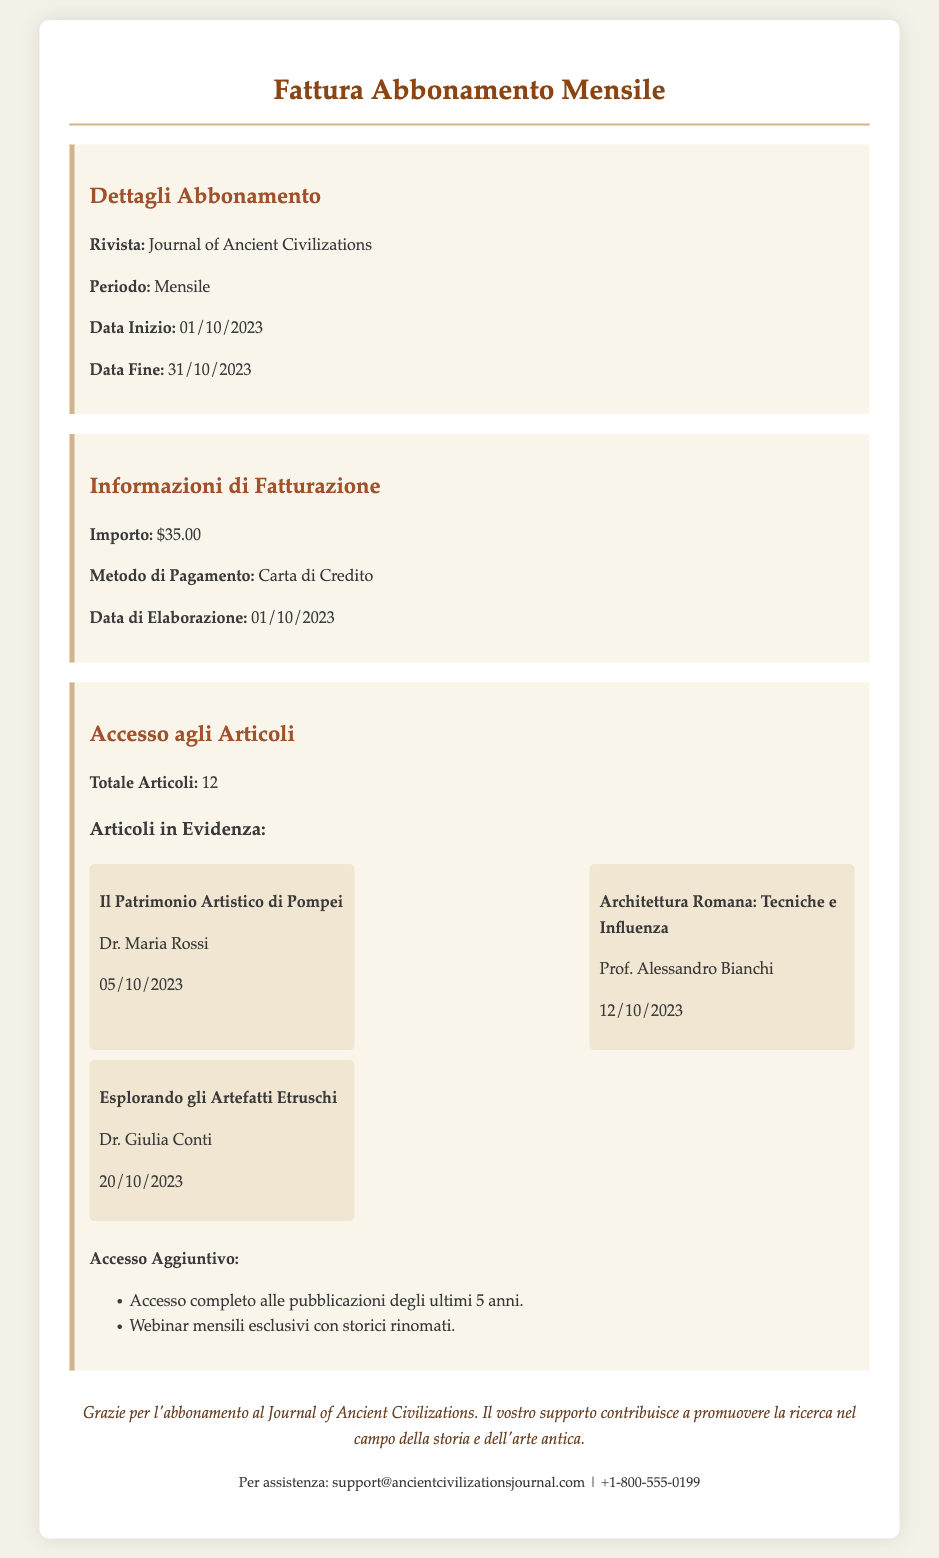Qual è il nome della rivista? La rivista è menzionata nel documento nei dettagli dell'abbonamento.
Answer: Journal of Ancient Civilizations Qual è l'importo della fattura? L'importo è elencato nelle informazioni di fatturazione nel documento.
Answer: $35.00 Qual è la data di inizio dell'abbonamento? La data di inizio è fornita nei dettagli dell'abbonamento.
Answer: 01/10/2023 Quanti articoli totali sono accessibili? Il totale degli articoli è specificato nella sezione di accesso agli articoli.
Answer: 12 Chi è l'autore del primo articolo in evidenza? Il primo articolo in evidenza ha un autore specificato nel documento.
Answer: Dr. Maria Rossi Qual è il metodo di pagamento utilizzato? Il metodo di pagamento è indicato nelle informazioni di fatturazione.
Answer: Carta di Credito Quando è stata elaborata la fattura? La data di elaborazione è menzionata nelle informazioni di fatturazione.
Answer: 01/10/2023 Qual è un vantaggio dell'abbonamento? I vantaggi sono elencati nella sezione di accesso agli articoli.
Answer: Accesso completo alle pubblicazioni degli ultimi 5 anni Qual è il titolo del secondo articolo in evidenza? Il titolo del secondo articolo è fornito nell'elenco degli articoli in evidenza.
Answer: Architettura Romana: Tecniche e Influenza 